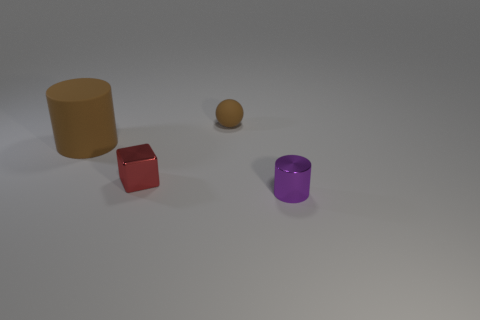Is there anything else that is the same size as the purple metallic cylinder?
Offer a very short reply. Yes. There is a metal object behind the purple metal object; does it have the same shape as the small shiny object that is in front of the red metallic object?
Your answer should be compact. No. Are there fewer small purple objects that are on the left side of the big brown matte cylinder than large brown matte things in front of the small red shiny cube?
Keep it short and to the point. No. What number of other objects are there of the same shape as the small red object?
Ensure brevity in your answer.  0. What is the shape of the small red object that is the same material as the small purple object?
Give a very brief answer. Cube. There is a tiny thing that is in front of the small rubber object and behind the tiny cylinder; what color is it?
Make the answer very short. Red. Are the tiny object behind the red cube and the purple cylinder made of the same material?
Give a very brief answer. No. Are there fewer tiny metal cylinders on the left side of the big brown object than green metallic blocks?
Your answer should be compact. No. Is there a tiny red cylinder that has the same material as the tiny brown ball?
Your answer should be very brief. No. Do the purple thing and the rubber object in front of the small matte thing have the same size?
Offer a very short reply. No. 